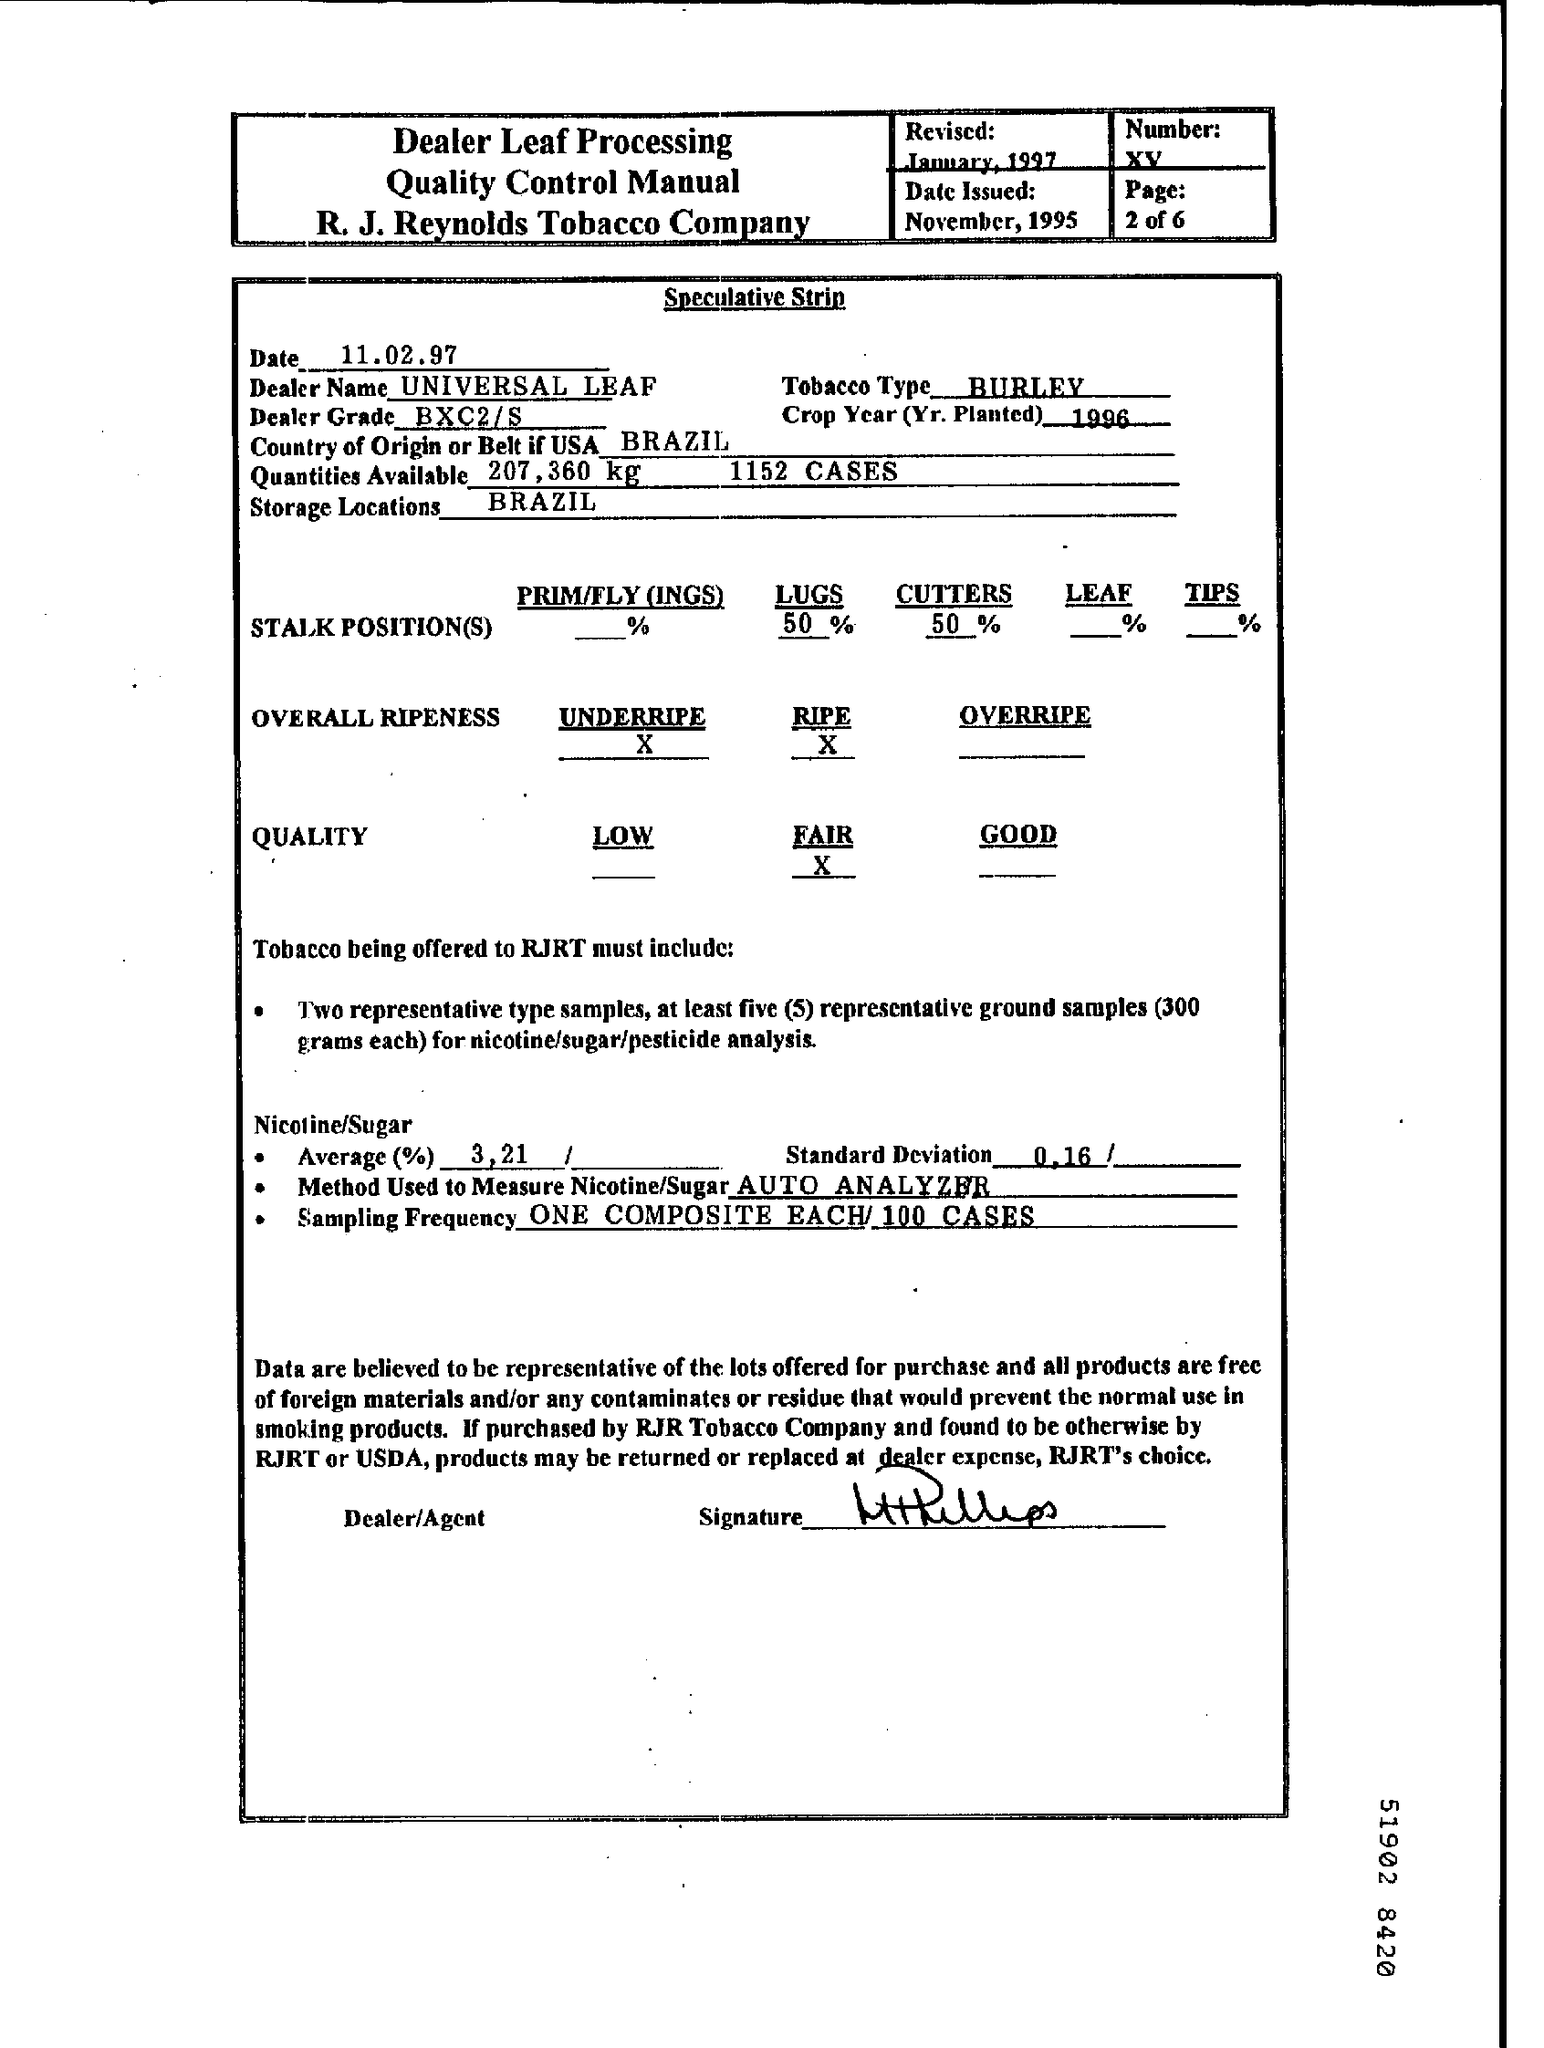When was it Revised?
Your response must be concise. January, 1997. What is the Number?
Offer a terse response. XV. When was the Date Issued?
Provide a short and direct response. November, 1995. What is the Date?
Your answer should be compact. 11.02.97. What is the Tobacco Type?
Make the answer very short. Burley. What is the Dealer Name?
Ensure brevity in your answer.  Universal Leaf. What is the Dealer Grade?
Provide a succinct answer. BXC2/S. What is the Country of Origin or Belt if USA?
Provide a succinct answer. Brazil. Where are the storage locations?
Your response must be concise. Brazil. What is the Crop Year (Yr. Planted)?
Ensure brevity in your answer.  1996. 